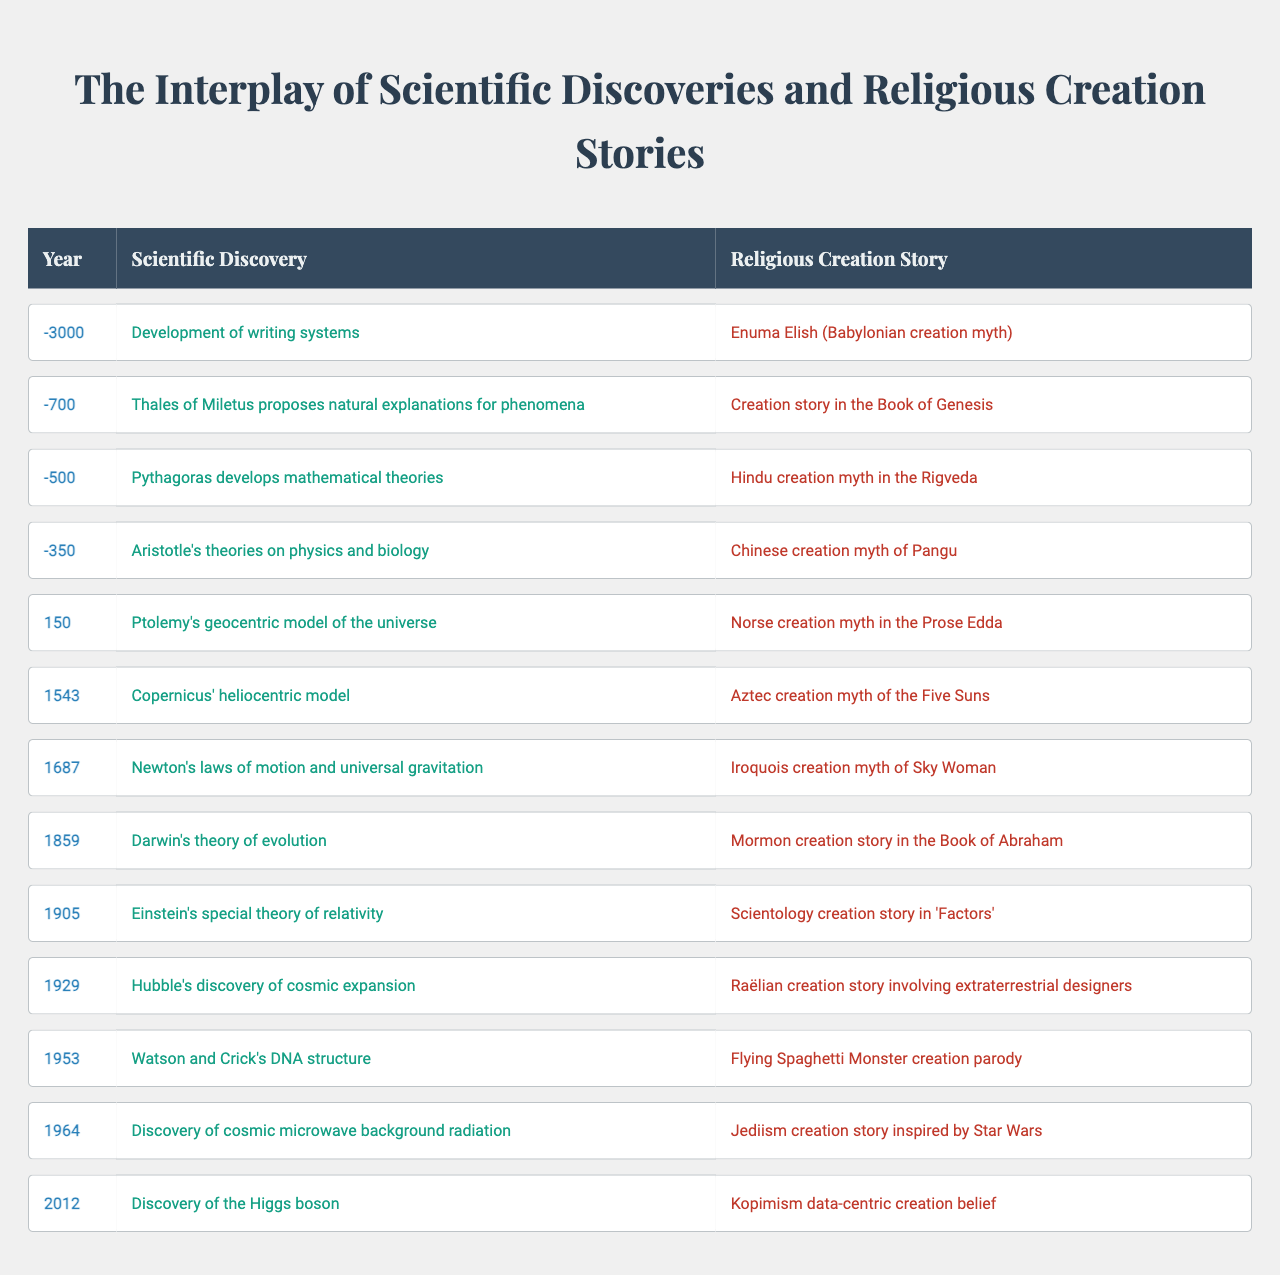What scientific discovery was made in 150? The table indicates that in the year 150, Ptolemy proposed the geocentric model of the universe.
Answer: Ptolemy's geocentric model What religious creation story corresponds to the year 1859? Referring to the table, the religious creation story for the year 1859 is the Mormon creation story in the Book of Abraham.
Answer: Mormon creation story in the Book of Abraham How many years apart were the discoveries of Newton’s laws of motion and Darwin’s theory of evolution? Newton’s laws were discovered in 1687 and Darwin’s theory was in 1859. The difference in years is 1859 - 1687 = 172 years.
Answer: 172 years Which scientific discovery occurred closest to 500 BC? The closest scientific discovery to 500 BC according to the table is Pythagoras’s mathematical theories at -500.
Answer: Pythagoras's mathematical theories Is there any year where a scientific discovery and a religious creation story are both documented? Yes, each year listed in the table includes both a scientific discovery and a corresponding religious creation story.
Answer: Yes What was the earliest scientific discovery listed in the table, and in what year did it occur? The earliest scientific discovery is the development of writing systems, which occurred in -3000.
Answer: Development of writing systems in -3000 What is the relationship between the years 150 and 1543 regarding scientific discoveries? The table shows that both years include significant scientific discoveries, with Ptolemy’s geocentric model in 150 and Copernicus’s heliocentric model in 1543, indicating a progression in astronomical understanding.
Answer: Ptolemy in 150 and Copernicus in 1543 show progression Is there a pattern in the timeline when scientific discoveries started to conflict with religious creation stories? Observing the table, conflict becomes notable with Darwin's theory of evolution in 1859, which contradicted many creationist beliefs, particularly of creation stories in the Book of Genesis.
Answer: Yes, noted from Darwin's theory in 1859 What major scientific discovery happened after the discovery of the DNA structure? The next major scientific discovery listed is the discovery of cosmic microwave background radiation in 1964.
Answer: Discovery of cosmic microwave background radiation in 1964 Based on the table, which discipline, scientific or religious, seems to have later entries? The later entries are primarily scientific discoveries, with the most recent being the discovery of the Higgs boson in 2012, while religious accounts like Kopimism emerged in the same period.
Answer: Scientific discoveries Which religious creation story is associated with the scientific discovery of the Higgs boson? The religious creation story linked with the scientific discovery of the Higgs boson in 2012 is the Kopimism data-centric creation belief.
Answer: Kopimism data-centric creation belief 